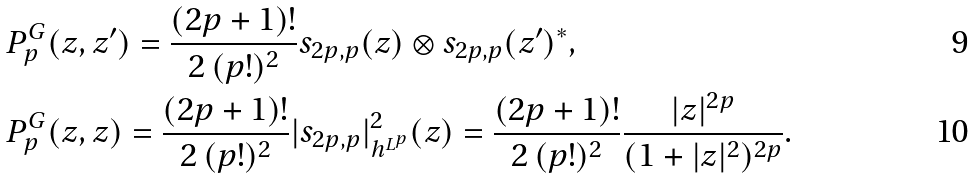Convert formula to latex. <formula><loc_0><loc_0><loc_500><loc_500>& P ^ { G } _ { p } ( z , z ^ { \prime } ) = \frac { ( 2 p + 1 ) ! } { 2 \, ( p ! ) ^ { 2 } } s _ { 2 p , p } ( z ) \otimes s _ { 2 p , p } ( z ^ { \prime } ) ^ { * } , \\ & P ^ { G } _ { p } ( z , z ) = \frac { ( 2 p + 1 ) ! } { 2 \, ( p ! ) ^ { 2 } } | s _ { 2 p , p } | _ { h ^ { L ^ { p } } } ^ { 2 } ( z ) = \frac { ( 2 p + 1 ) ! } { 2 \, ( p ! ) ^ { 2 } } \frac { | z | ^ { 2 p } } { ( 1 + | z | ^ { 2 } ) ^ { 2 p } } .</formula> 